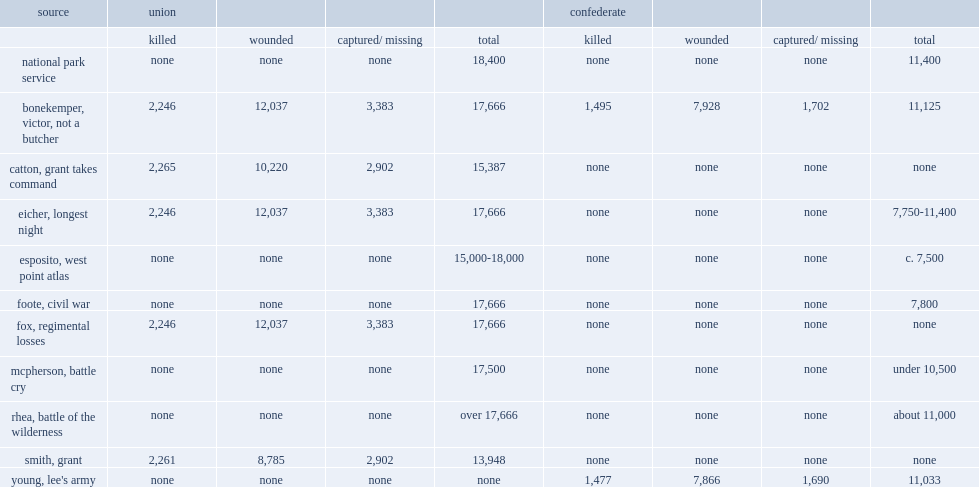How many casualties did mcpherson have totally? 17500.0. 